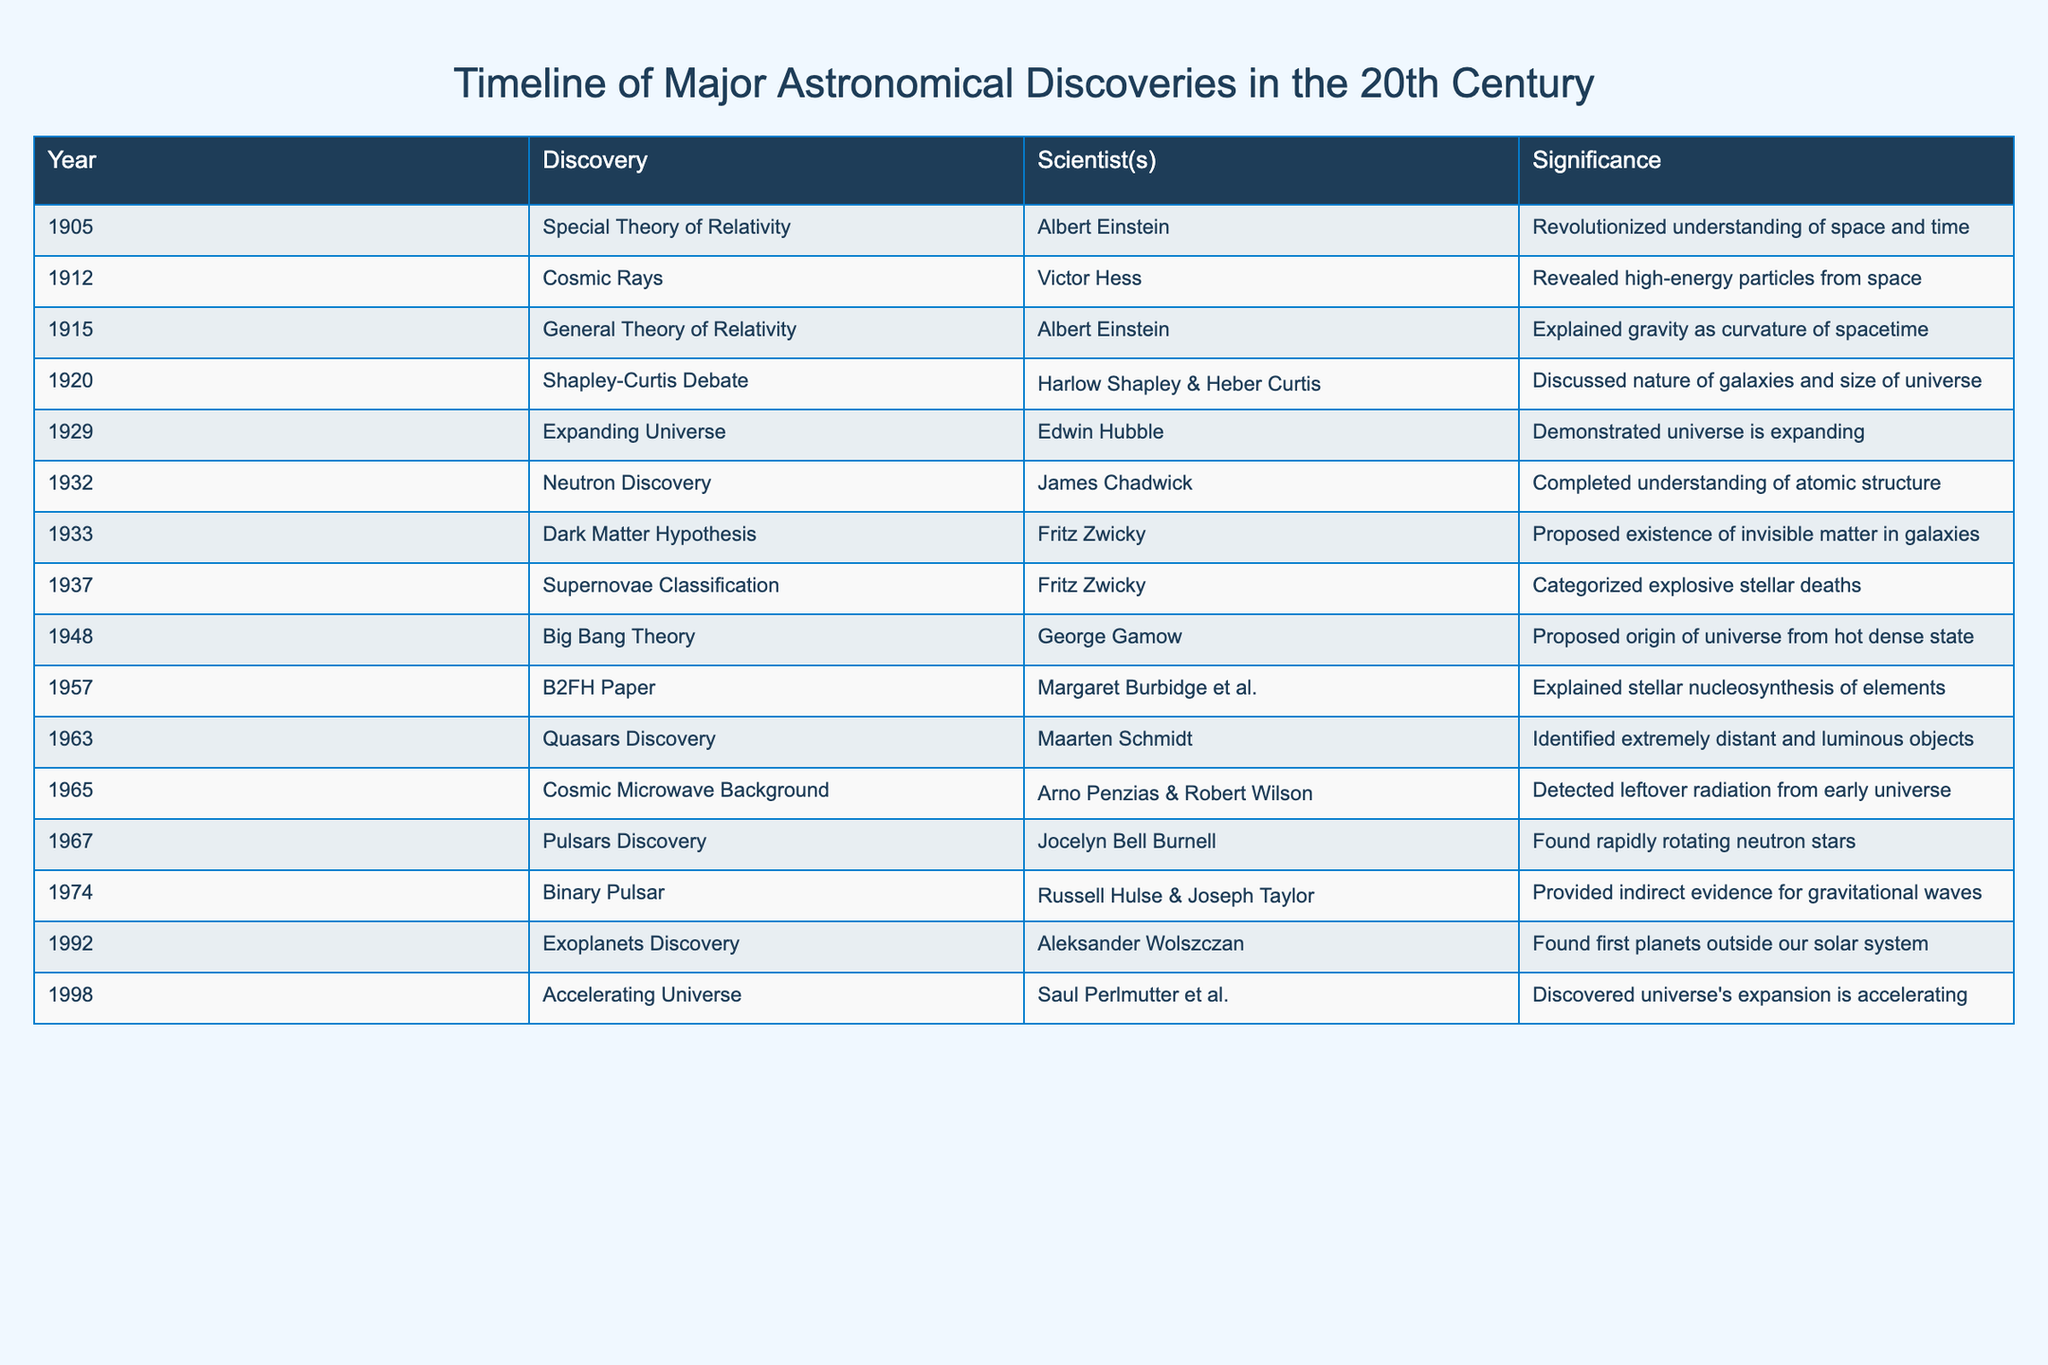What was the first major astronomical discovery listed in the table? The first entry in the table shows the discovery for the year 1905, which corresponds to the "Special Theory of Relativity" made by Albert Einstein.
Answer: Special Theory of Relativity How many discoveries were made before the year 1950? By counting the entries in the table prior to 1950, there are 9 discoveries listed (from 1905 to 1948).
Answer: 9 Who proposed the Dark Matter Hypothesis and in what year? The Dark Matter Hypothesis was proposed by Fritz Zwicky in the year 1933, as indicated in the table.
Answer: Fritz Zwicky, 1933 Is the discovery of Cosmic Rays associated with Albert Einstein? The table specifies that Cosmic Rays were discovered by Victor Hess, not Albert Einstein, so the answer is no.
Answer: No What discovery occurred in 1965 and what was its significance? The table shows that in 1965, the Cosmic Microwave Background radiation was detected by Arno Penzias and Robert Wilson, which is significant as it represents leftover radiation from the early universe.
Answer: Cosmic Microwave Background; leftover radiation from early universe What percentage of the discoveries in the table are related to the concept of the universe's expansion or structure? There are 4 relevant discoveries (Expanding Universe in 1929, Big Bang Theory in 1948, Accelerating Universe in 1998, and Cosmic Microwave Background in 1965). With 15 total discoveries, the percentage is (4/15)*100 = 26.67%.
Answer: 26.67% Which scientist is mentioned for the discovery of Exoplanets in 1992, and what was the impact of this discovery? Aleksander Wolszczan is the scientist credited with discovering Exoplanets in 1992, marking the first discovery of planets outside our solar system, which fundamentally changed our understanding of planetary systems.
Answer: Aleksander Wolszczan; first planets outside our solar system What is the timeframe between the discovery of Neutron and the discovery of Pulsars? The Neutron was discovered in 1932 and Pulsars in 1967. To find the timeframe, subtract 1932 from 1967, which equals 35 years.
Answer: 35 years Which two scientists discovered the first evidence for gravitational waves, and when was this discovery made? The table lists that Russell Hulse and Joseph Taylor provided indirect evidence for gravitational waves in 1974.
Answer: Russell Hulse & Joseph Taylor, 1974 Which concept did Maarten Schmidt identify in 1963? According to the table, Maarten Schmidt identified Quasars in 1963 as extremely distant and luminous objects, which enhanced our understanding of celestial phenomena.
Answer: Quasars How many discoveries occurred in the 1930s? There are 4 discoveries listed in the 1930s (1932 Neutron Discovery, 1933 Dark Matter Hypothesis, 1937 Supernovae Classification).
Answer: 4 